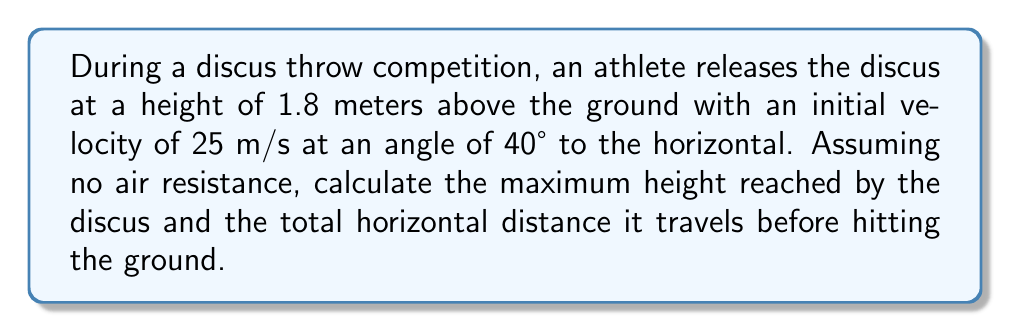What is the answer to this math problem? To solve this problem, we'll use the principles of parabolic motion and trigonometry. Let's break it down step by step:

1. First, let's identify the known variables:
   - Initial height ($h_0$) = 1.8 m
   - Initial velocity ($v_0$) = 25 m/s
   - Angle of release ($\theta$) = 40°
   - Acceleration due to gravity ($g$) = 9.8 m/s²

2. Calculate the initial vertical and horizontal components of velocity:
   $v_{0x} = v_0 \cos\theta = 25 \cos 40° = 19.15$ m/s
   $v_{0y} = v_0 \sin\theta = 25 \sin 40° = 16.07$ m/s

3. To find the maximum height, we use the equation:
   $$h_{max} = h_0 + \frac{v_{0y}^2}{2g}$$
   $$h_{max} = 1.8 + \frac{16.07^2}{2(9.8)} = 1.8 + 13.16 = 14.96$$ m

4. To find the time of flight, we need to solve the quadratic equation:
   $$0 = h_0 + v_{0y}t - \frac{1}{2}gt^2$$
   $$0 = 1.8 + 16.07t - 4.9t^2$$
   
   Using the quadratic formula, we get:
   $$t = \frac{16.07 \pm \sqrt{16.07^2 + 4(4.9)(1.8)}}{2(4.9)} = 3.44$$ s

5. The horizontal distance traveled is:
   $$d = v_{0x}t = 19.15 \times 3.44 = 65.88$$ m

Therefore, the maximum height reached by the discus is 14.96 m, and the total horizontal distance traveled is 65.88 m.
Answer: Maximum height: 14.96 m
Horizontal distance: 65.88 m 